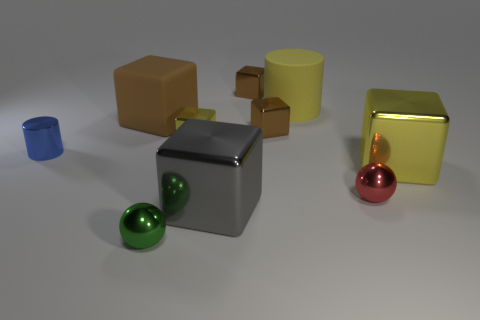How many yellow objects have the same material as the green ball?
Your answer should be compact. 2. The sphere that is made of the same material as the tiny green thing is what color?
Ensure brevity in your answer.  Red. Do the red metallic thing and the block to the right of the large yellow rubber thing have the same size?
Ensure brevity in your answer.  No. What material is the brown object left of the metal cube behind the large rubber object to the left of the green shiny object?
Your response must be concise. Rubber. What number of things are either cyan matte cylinders or large gray objects?
Provide a short and direct response. 1. There is a cylinder right of the tiny metallic cylinder; does it have the same color as the big metallic thing that is right of the large rubber cylinder?
Your response must be concise. Yes. What shape is the blue thing that is the same size as the red metallic object?
Offer a terse response. Cylinder. What number of objects are either large blocks behind the red shiny thing or big cubes to the left of the tiny green ball?
Give a very brief answer. 2. Are there fewer big purple cylinders than green metal spheres?
Give a very brief answer. Yes. What is the material of the yellow block that is the same size as the red ball?
Provide a succinct answer. Metal. 